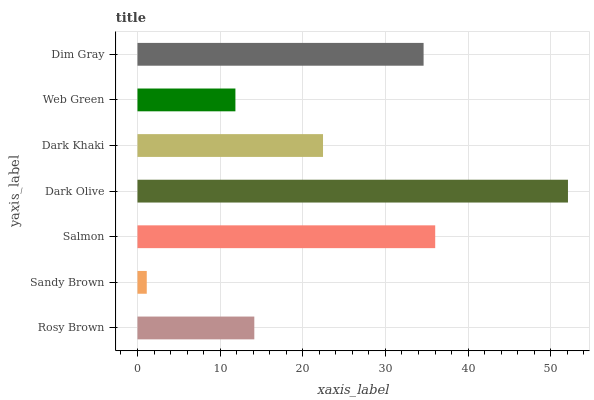Is Sandy Brown the minimum?
Answer yes or no. Yes. Is Dark Olive the maximum?
Answer yes or no. Yes. Is Salmon the minimum?
Answer yes or no. No. Is Salmon the maximum?
Answer yes or no. No. Is Salmon greater than Sandy Brown?
Answer yes or no. Yes. Is Sandy Brown less than Salmon?
Answer yes or no. Yes. Is Sandy Brown greater than Salmon?
Answer yes or no. No. Is Salmon less than Sandy Brown?
Answer yes or no. No. Is Dark Khaki the high median?
Answer yes or no. Yes. Is Dark Khaki the low median?
Answer yes or no. Yes. Is Dim Gray the high median?
Answer yes or no. No. Is Rosy Brown the low median?
Answer yes or no. No. 